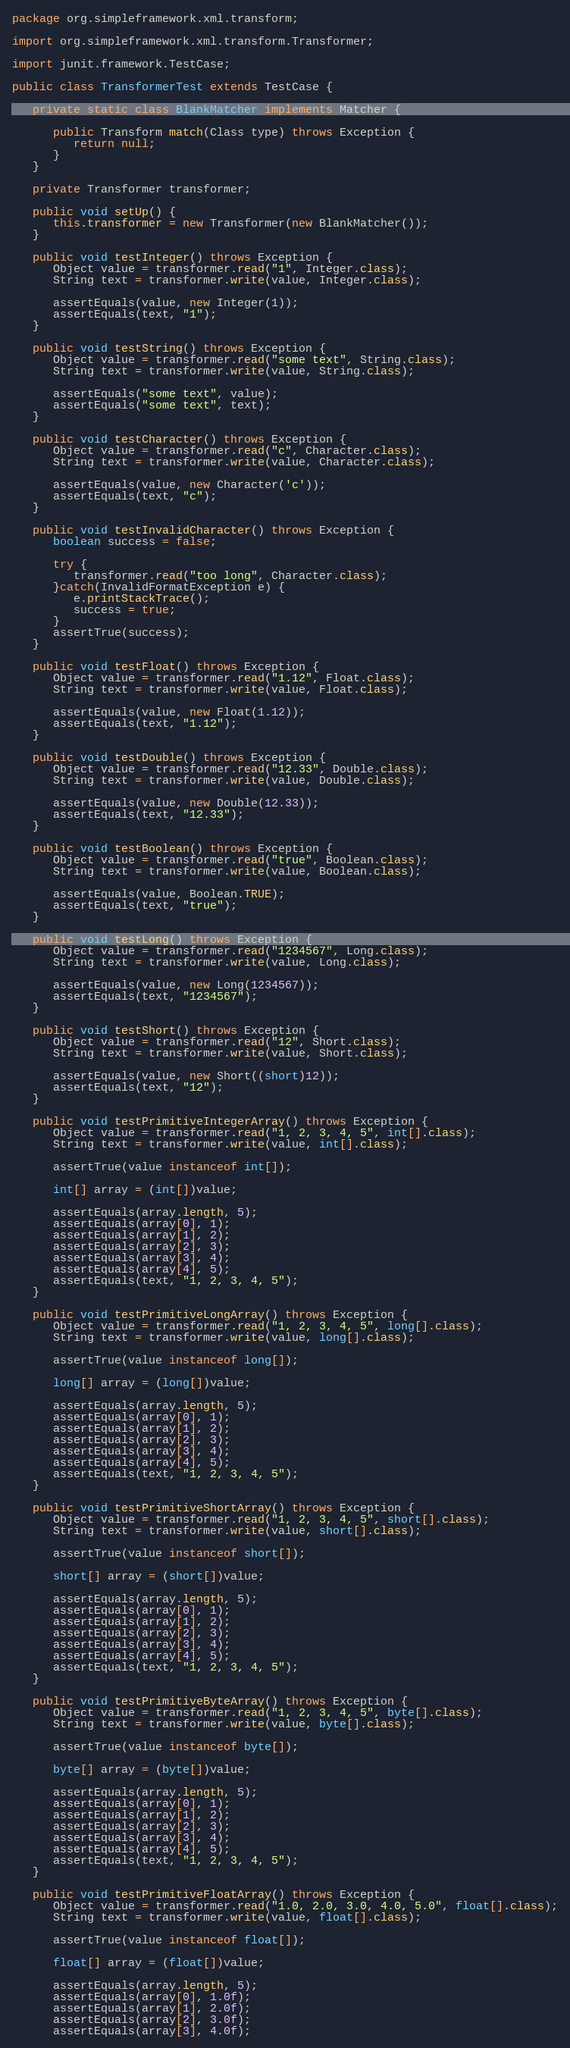Convert code to text. <code><loc_0><loc_0><loc_500><loc_500><_Java_>package org.simpleframework.xml.transform;

import org.simpleframework.xml.transform.Transformer;

import junit.framework.TestCase;

public class TransformerTest extends TestCase {
   
   private static class BlankMatcher implements Matcher {

      public Transform match(Class type) throws Exception {
         return null;
      }
   }
   
   private Transformer transformer;
   
   public void setUp() {
      this.transformer = new Transformer(new BlankMatcher());
   }

   public void testInteger() throws Exception {     
      Object value = transformer.read("1", Integer.class);
      String text = transformer.write(value, Integer.class);

      assertEquals(value, new Integer(1));
      assertEquals(text, "1");
   }
   
   public void testString() throws Exception {     
      Object value = transformer.read("some text", String.class);      
      String text = transformer.write(value, String.class);
      
      assertEquals("some text", value);
      assertEquals("some text", text);
   }
   
   public void testCharacter() throws Exception {
      Object value = transformer.read("c", Character.class);      
      String text = transformer.write(value, Character.class);      
      
      assertEquals(value, new Character('c'));
      assertEquals(text, "c");
   }
   
   public void testInvalidCharacter() throws Exception {
      boolean success = false;
      
      try {
         transformer.read("too long", Character.class);
      }catch(InvalidFormatException e) {
         e.printStackTrace();
         success = true;
      }
      assertTrue(success);
   }
   
   public void testFloat() throws Exception {
      Object value = transformer.read("1.12", Float.class);      
      String text = transformer.write(value, Float.class);
      
      assertEquals(value, new Float(1.12));
      assertEquals(text, "1.12");
   }
   
   public void testDouble() throws Exception {     
      Object value = transformer.read("12.33", Double.class);
      String text = transformer.write(value, Double.class);      
      
      assertEquals(value, new Double(12.33));
      assertEquals(text, "12.33");
   }
   
   public void testBoolean() throws Exception {
      Object value = transformer.read("true", Boolean.class);
      String text = transformer.write(value, Boolean.class);
      
      assertEquals(value, Boolean.TRUE);
      assertEquals(text, "true");
   }
   
   public void testLong() throws Exception {
      Object value = transformer.read("1234567", Long.class);
      String text = transformer.write(value, Long.class);
      
      assertEquals(value, new Long(1234567));
      assertEquals(text, "1234567");
   }
   
   public void testShort() throws Exception {
      Object value = transformer.read("12", Short.class);
      String text = transformer.write(value, Short.class);
      
      assertEquals(value, new Short((short)12));
      assertEquals(text, "12");
   }
   
   public void testPrimitiveIntegerArray() throws Exception {
      Object value = transformer.read("1, 2, 3, 4, 5", int[].class);
      String text = transformer.write(value, int[].class);
      
      assertTrue(value instanceof int[]);

      int[] array = (int[])value;

      assertEquals(array.length, 5);
      assertEquals(array[0], 1);
      assertEquals(array[1], 2);
      assertEquals(array[2], 3);
      assertEquals(array[3], 4);
      assertEquals(array[4], 5);
      assertEquals(text, "1, 2, 3, 4, 5");      
   }
   
   public void testPrimitiveLongArray() throws Exception {
      Object value = transformer.read("1, 2, 3, 4, 5", long[].class);
      String text = transformer.write(value, long[].class);
      
      assertTrue(value instanceof long[]);

      long[] array = (long[])value;

      assertEquals(array.length, 5);
      assertEquals(array[0], 1);
      assertEquals(array[1], 2);
      assertEquals(array[2], 3);
      assertEquals(array[3], 4);
      assertEquals(array[4], 5);
      assertEquals(text, "1, 2, 3, 4, 5");      
   }     
   
   public void testPrimitiveShortArray() throws Exception {
      Object value = transformer.read("1, 2, 3, 4, 5", short[].class);
      String text = transformer.write(value, short[].class);
      
      assertTrue(value instanceof short[]);

      short[] array = (short[])value;

      assertEquals(array.length, 5);
      assertEquals(array[0], 1);
      assertEquals(array[1], 2);
      assertEquals(array[2], 3);
      assertEquals(array[3], 4);
      assertEquals(array[4], 5);
      assertEquals(text, "1, 2, 3, 4, 5");      
   }
   
   public void testPrimitiveByteArray() throws Exception {
      Object value = transformer.read("1, 2, 3, 4, 5", byte[].class);
      String text = transformer.write(value, byte[].class);
      
      assertTrue(value instanceof byte[]);

      byte[] array = (byte[])value;

      assertEquals(array.length, 5);
      assertEquals(array[0], 1);
      assertEquals(array[1], 2);
      assertEquals(array[2], 3);
      assertEquals(array[3], 4);
      assertEquals(array[4], 5);
      assertEquals(text, "1, 2, 3, 4, 5");      
   }
   
   public void testPrimitiveFloatArray() throws Exception {
      Object value = transformer.read("1.0, 2.0, 3.0, 4.0, 5.0", float[].class);
      String text = transformer.write(value, float[].class);
      
      assertTrue(value instanceof float[]);

      float[] array = (float[])value;

      assertEquals(array.length, 5);
      assertEquals(array[0], 1.0f);
      assertEquals(array[1], 2.0f);
      assertEquals(array[2], 3.0f);
      assertEquals(array[3], 4.0f);</code> 